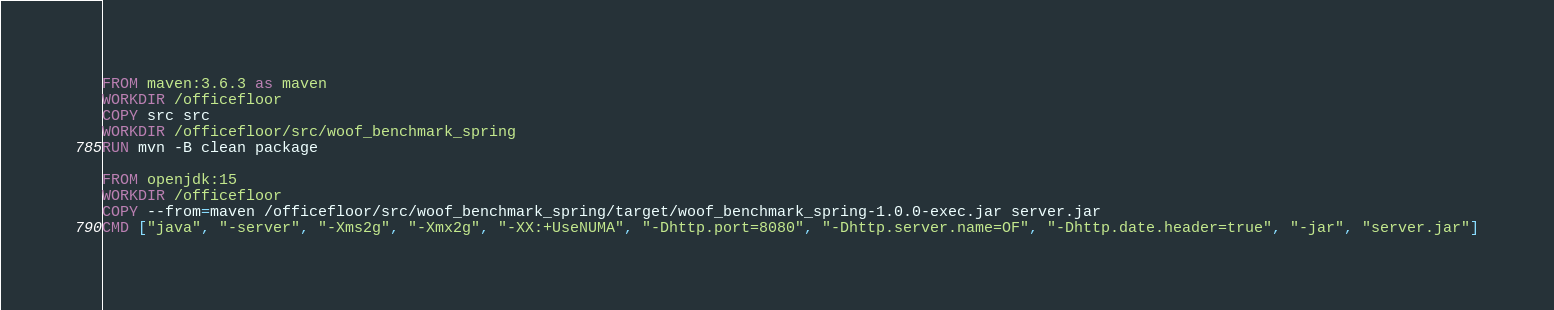Convert code to text. <code><loc_0><loc_0><loc_500><loc_500><_Dockerfile_>FROM maven:3.6.3 as maven
WORKDIR /officefloor
COPY src src
WORKDIR /officefloor/src/woof_benchmark_spring
RUN mvn -B clean package

FROM openjdk:15
WORKDIR /officefloor
COPY --from=maven /officefloor/src/woof_benchmark_spring/target/woof_benchmark_spring-1.0.0-exec.jar server.jar
CMD ["java", "-server", "-Xms2g", "-Xmx2g", "-XX:+UseNUMA", "-Dhttp.port=8080", "-Dhttp.server.name=OF", "-Dhttp.date.header=true", "-jar", "server.jar"]
</code> 